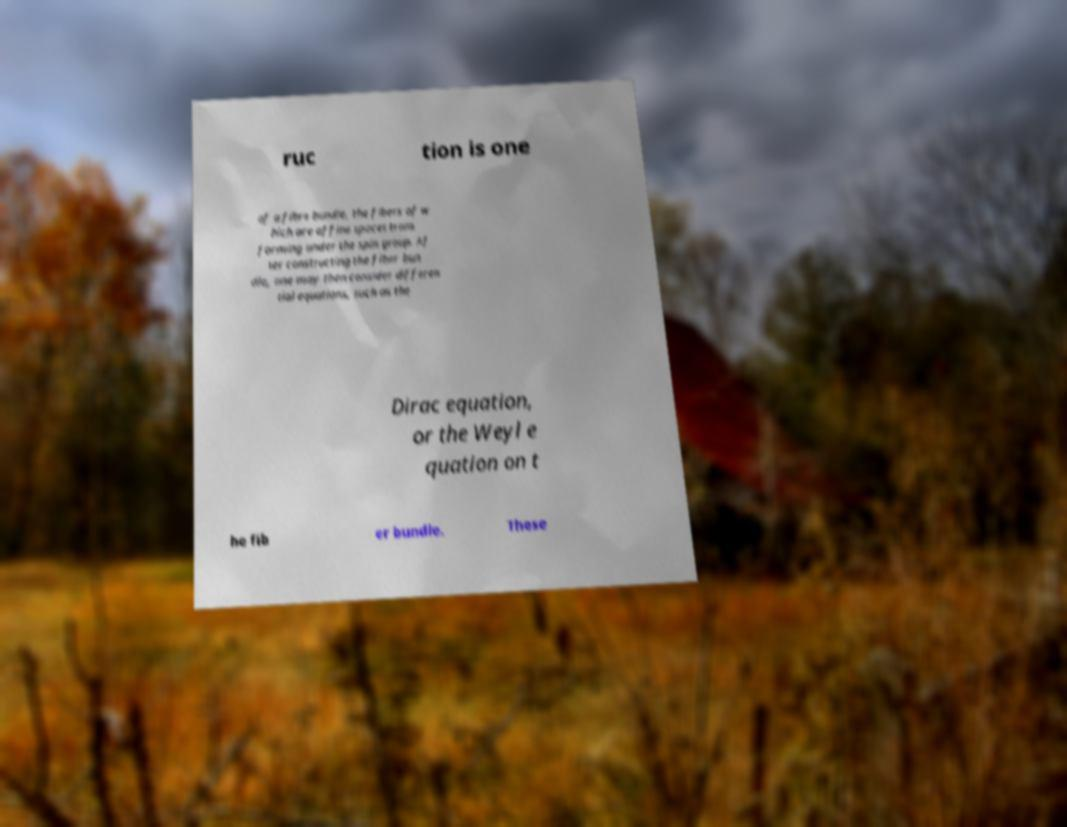Could you assist in decoding the text presented in this image and type it out clearly? ruc tion is one of a fibre bundle, the fibers of w hich are affine spaces trans forming under the spin group. Af ter constructing the fiber bun dle, one may then consider differen tial equations, such as the Dirac equation, or the Weyl e quation on t he fib er bundle. These 